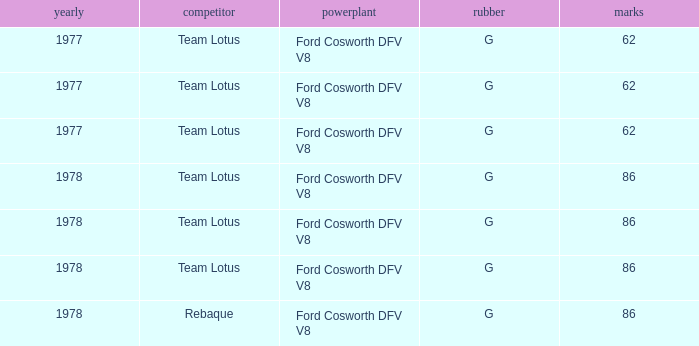What is the Focus that has a Year bigger than 1977? 86, 86, 86, 86. 